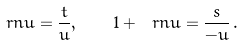<formula> <loc_0><loc_0><loc_500><loc_500>\ r n u = \frac { t } { u } , \quad 1 + \ r n u = \frac { s } { - u } \, .</formula> 